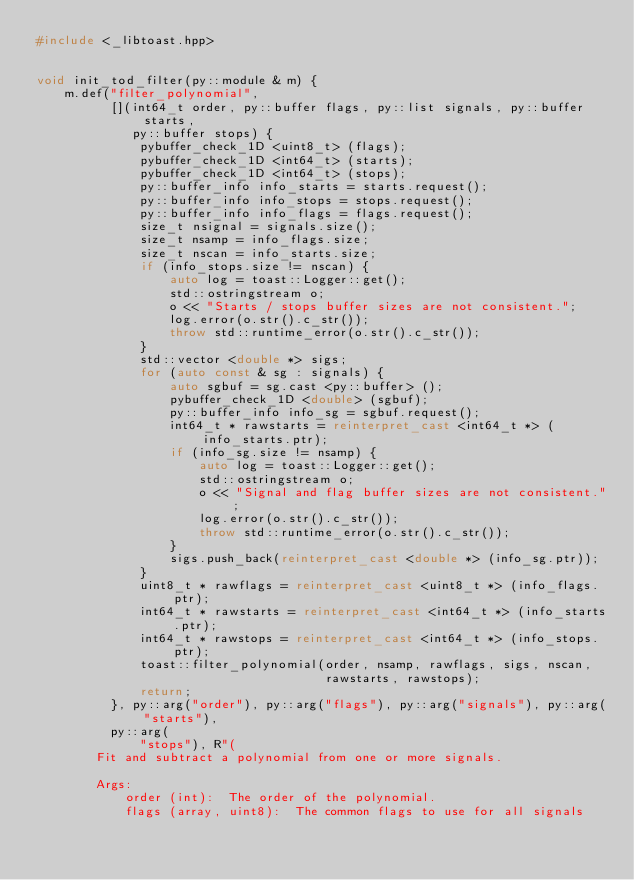<code> <loc_0><loc_0><loc_500><loc_500><_C++_>#include <_libtoast.hpp>


void init_tod_filter(py::module & m) {
    m.def("filter_polynomial",
          [](int64_t order, py::buffer flags, py::list signals, py::buffer starts,
             py::buffer stops) {
              pybuffer_check_1D <uint8_t> (flags);
              pybuffer_check_1D <int64_t> (starts);
              pybuffer_check_1D <int64_t> (stops);
              py::buffer_info info_starts = starts.request();
              py::buffer_info info_stops = stops.request();
              py::buffer_info info_flags = flags.request();
              size_t nsignal = signals.size();
              size_t nsamp = info_flags.size;
              size_t nscan = info_starts.size;
              if (info_stops.size != nscan) {
                  auto log = toast::Logger::get();
                  std::ostringstream o;
                  o << "Starts / stops buffer sizes are not consistent.";
                  log.error(o.str().c_str());
                  throw std::runtime_error(o.str().c_str());
              }
              std::vector <double *> sigs;
              for (auto const & sg : signals) {
                  auto sgbuf = sg.cast <py::buffer> ();
                  pybuffer_check_1D <double> (sgbuf);
                  py::buffer_info info_sg = sgbuf.request();
                  int64_t * rawstarts = reinterpret_cast <int64_t *> (info_starts.ptr);
                  if (info_sg.size != nsamp) {
                      auto log = toast::Logger::get();
                      std::ostringstream o;
                      o << "Signal and flag buffer sizes are not consistent.";
                      log.error(o.str().c_str());
                      throw std::runtime_error(o.str().c_str());
                  }
                  sigs.push_back(reinterpret_cast <double *> (info_sg.ptr));
              }
              uint8_t * rawflags = reinterpret_cast <uint8_t *> (info_flags.ptr);
              int64_t * rawstarts = reinterpret_cast <int64_t *> (info_starts.ptr);
              int64_t * rawstops = reinterpret_cast <int64_t *> (info_stops.ptr);
              toast::filter_polynomial(order, nsamp, rawflags, sigs, nscan,
                                       rawstarts, rawstops);
              return;
          }, py::arg("order"), py::arg("flags"), py::arg("signals"), py::arg("starts"),
          py::arg(
              "stops"), R"(
        Fit and subtract a polynomial from one or more signals.

        Args:
            order (int):  The order of the polynomial.
            flags (array, uint8):  The common flags to use for all signals</code> 